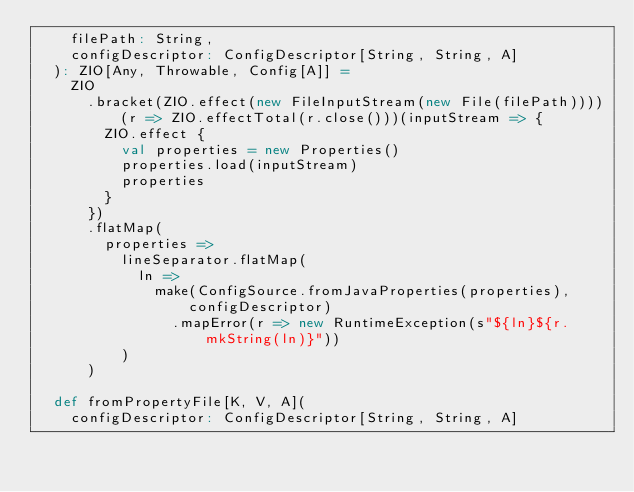<code> <loc_0><loc_0><loc_500><loc_500><_Scala_>    filePath: String,
    configDescriptor: ConfigDescriptor[String, String, A]
  ): ZIO[Any, Throwable, Config[A]] =
    ZIO
      .bracket(ZIO.effect(new FileInputStream(new File(filePath))))(r => ZIO.effectTotal(r.close()))(inputStream => {
        ZIO.effect {
          val properties = new Properties()
          properties.load(inputStream)
          properties
        }
      })
      .flatMap(
        properties =>
          lineSeparator.flatMap(
            ln =>
              make(ConfigSource.fromJavaProperties(properties), configDescriptor)
                .mapError(r => new RuntimeException(s"${ln}${r.mkString(ln)}"))
          )
      )

  def fromPropertyFile[K, V, A](
    configDescriptor: ConfigDescriptor[String, String, A]</code> 